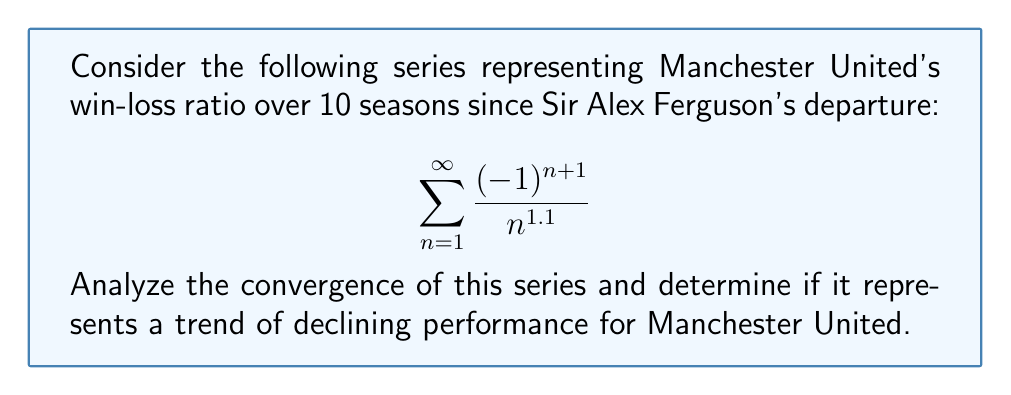Give your solution to this math problem. Let's approach this step-by-step:

1) First, we need to identify what type of series this is. The general term is $a_n = \frac{(-1)^{n+1}}{n^{1.1}}$, which alternates in sign due to the $(-1)^{n+1}$ term. This is an alternating series.

2) For alternating series, we can use the Alternating Series Test (also known as Leibniz Test). This test states that if:
   a) $|a_n| \geq |a_{n+1}|$ for all $n \geq N$ for some $N$
   b) $\lim_{n \to \infty} |a_n| = 0$
   Then the series converges.

3) Let's check condition (a):
   $|a_n| = \frac{1}{n^{1.1}}$ and $|a_{n+1}| = \frac{1}{(n+1)^{1.1}}$
   Clearly, $\frac{1}{n^{1.1}} \geq \frac{1}{(n+1)^{1.1}}$ for all $n \geq 1$, so condition (a) is satisfied.

4) Now, let's check condition (b):
   $\lim_{n \to \infty} |a_n| = \lim_{n \to \infty} \frac{1}{n^{1.1}} = 0$
   So condition (b) is also satisfied.

5) Since both conditions of the Alternating Series Test are met, we can conclude that the series converges.

6) To interpret this in the context of Manchester United's performance:
   - The alternating nature of the series suggests fluctuations in performance.
   - The decreasing magnitude of terms ($\frac{1}{n^{1.1}}$) indicates that these fluctuations become less pronounced over time.
   - The overall convergence suggests that the win-loss ratio stabilizes in the long run, rather than showing a clear declining trend.

Therefore, while the series converges mathematically, it doesn't necessarily represent a trend of declining performance for Manchester United. Instead, it suggests a pattern of fluctuating performance that eventually stabilizes.
Answer: The series converges but doesn't indicate a declining trend. 